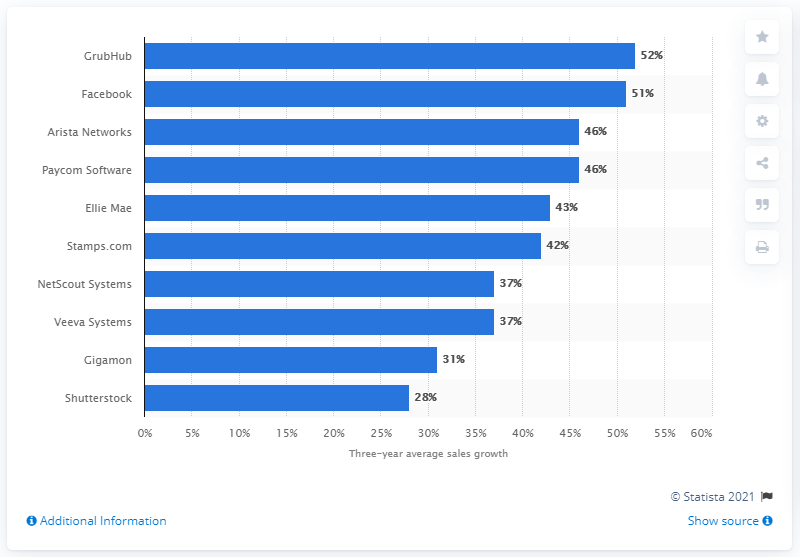List a handful of essential elements in this visual. In 2014, a food delivery platform named GrubHub went public. 